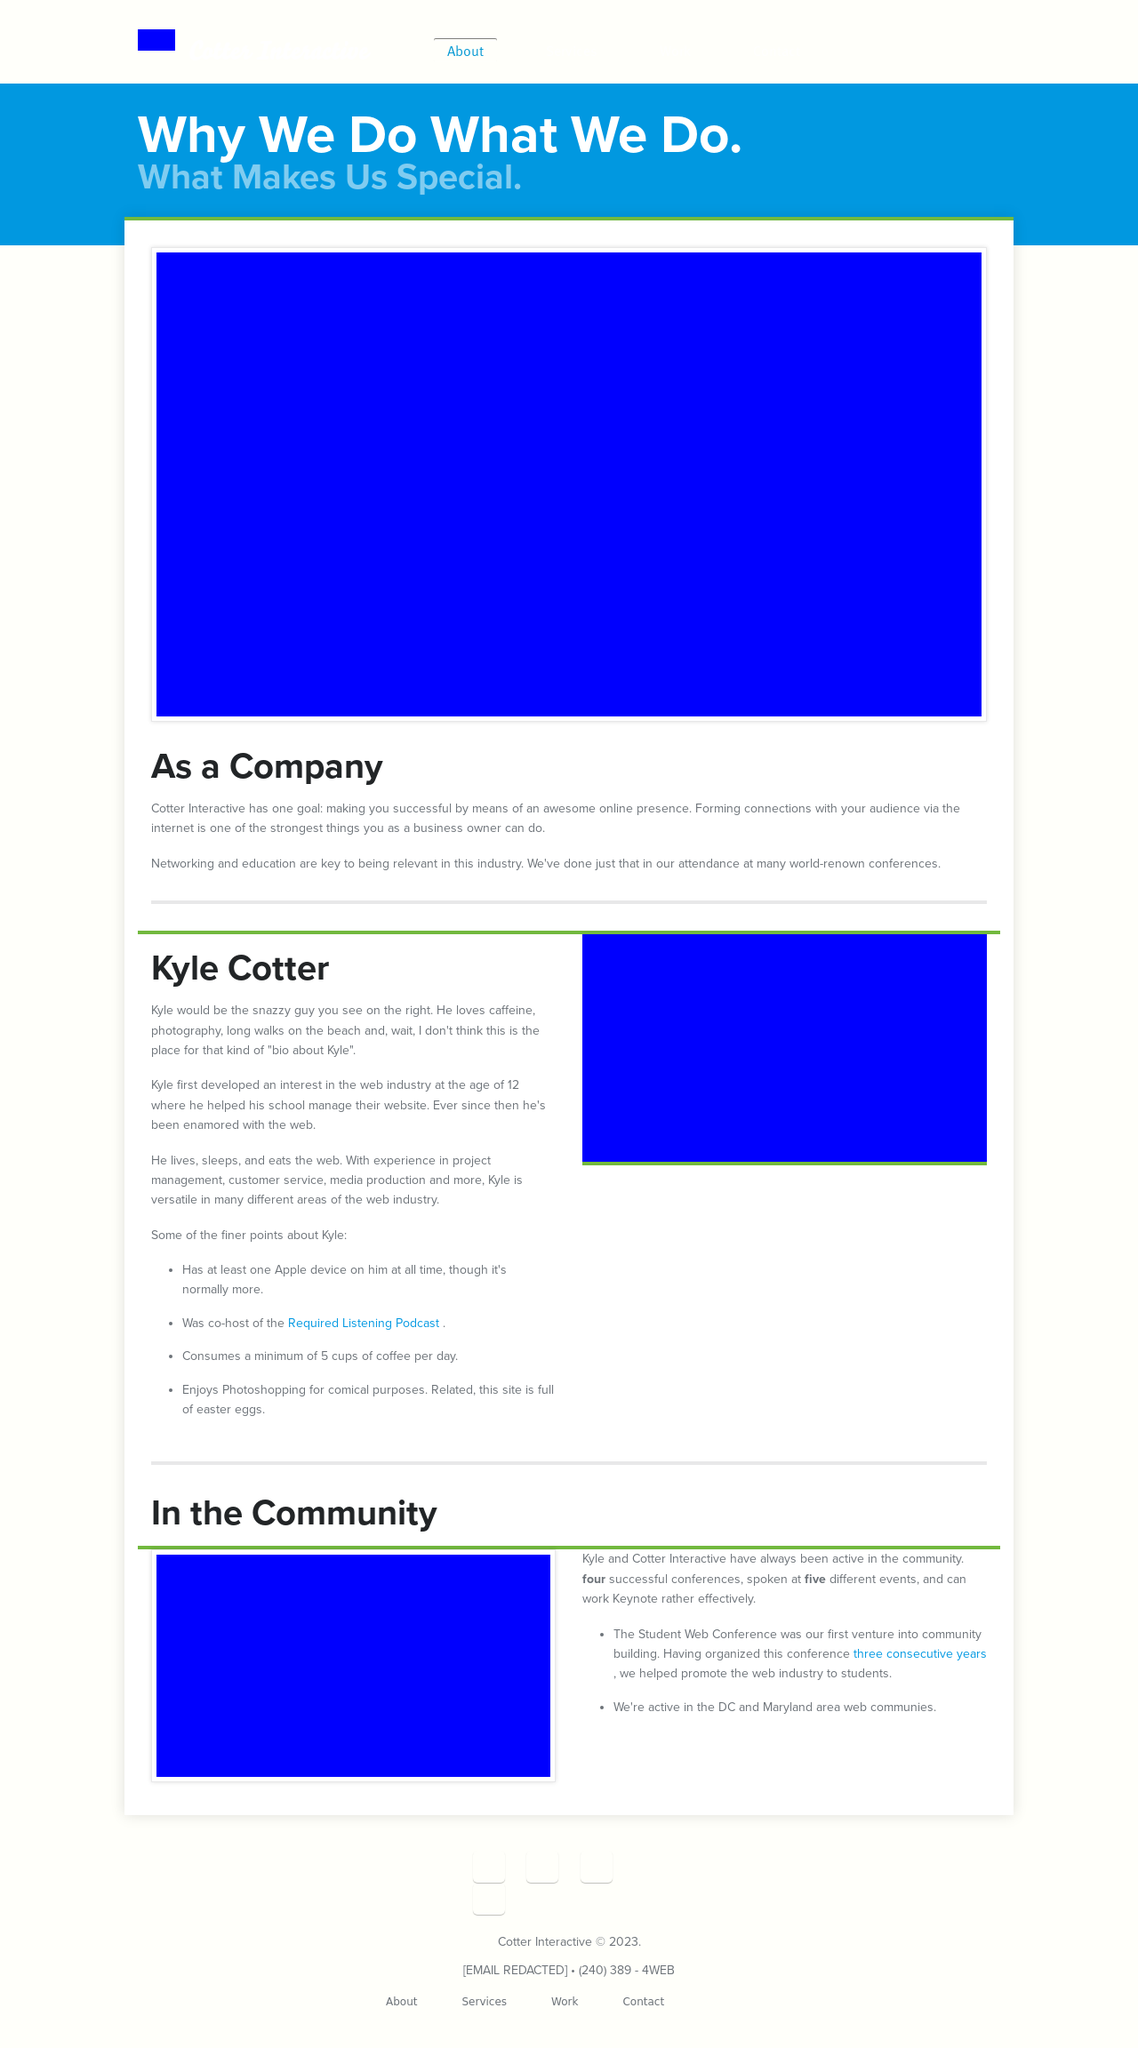Can you provide more details about the 'About' section shown in the website image? The 'About' section of the website appears structured to provide visitors with key information about the company. It outlines the company's goals, its team, and highlights how they engage with the community. Such a section is crucial as it helps build trust and establish a brand identity, encouraging user interaction and potential business opportunities. 